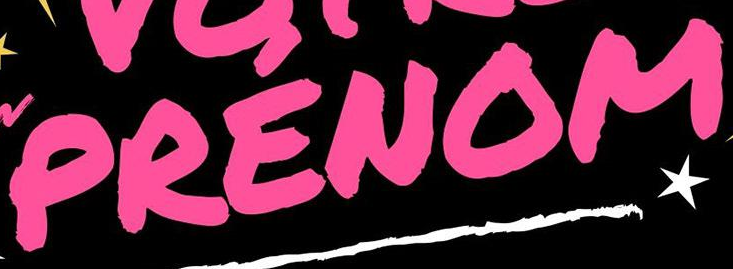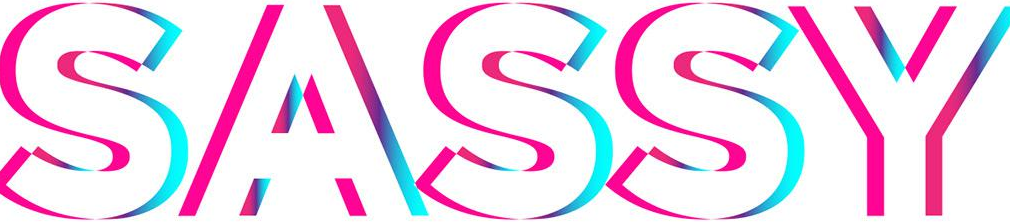What text appears in these images from left to right, separated by a semicolon? PRENOM; SASSY 